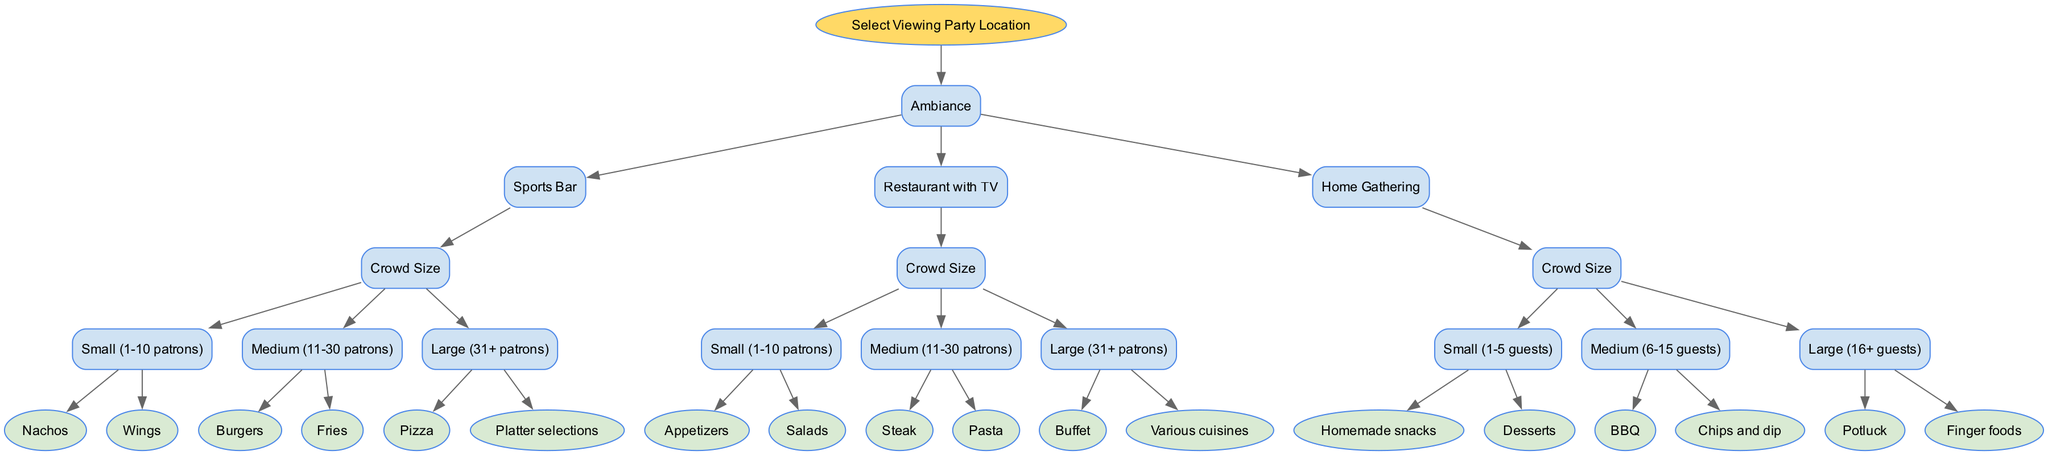What is the first decision to make in selecting a viewing party location? The first decision is to choose the type of location based on ambiance. The three options given are Sports Bar, Restaurant with TV, and Home Gathering.
Answer: Ambiance How many food options are available for a medium-sized crowd in a Sports Bar? In a Sports Bar, the food options for a medium-sized crowd (11-30 patrons) are Burgers and Fries, which totals to two options.
Answer: 2 What type of food options are provided for a large crowd in a Restaurant with TV? For a large crowd (31+ patrons) at a Restaurant with TV, the food options are Buffet and Various cuisines.
Answer: Buffet, Various cuisines If I want to have homemade snacks for my viewing party, what crowd size should I choose? Homemade snacks are available for a small crowd (1-5 guests) in a Home Gathering setup, therefore, choosing this crowd size will provide those options.
Answer: Small (1-5 guests) How many total food options are available across the different crowd sizes for Home Gathering? For Home Gathering, the food options are 2 for small (Homemade snacks, Desserts), 2 for medium (BBQ, Chips and dip), and 2 for large (Potluck, Finger foods). This sums up to a total of 6 food options.
Answer: 6 What is the ambiance choice that offers the largest food selection for large crowd sizes? The ambiance choice that provides the largest food selection for large crowd sizes is a Restaurant with TV, which offers a Buffet and Various cuisines.
Answer: Restaurant with TV Which location type provides appetizers for a small crowd? A Restaurant with TV provides appetizers for a small crowd (1-10 patrons), making it the correct location type for that food option.
Answer: Restaurant with TV What is the food choice for a small-sized crowd in a Sports Bar? The food choices for a small (1-10 patrons) crowd in a Sports Bar include Nachos and Wings, giving two options.
Answer: Nachos, Wings What is the maximum crowd size that allows for homemade desserts in a viewing party? Homemade desserts are offered for a small crowd (1-5 guests) in a Home Gathering, so the maximum crowd size for that option is 5 guests.
Answer: 5 guests 